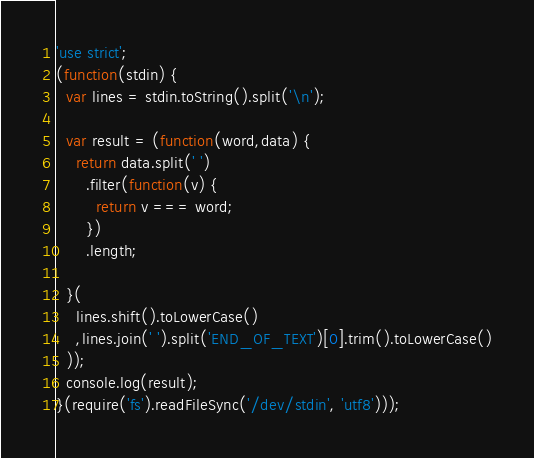<code> <loc_0><loc_0><loc_500><loc_500><_JavaScript_>'use strict';
(function(stdin) {
  var lines = stdin.toString().split('\n');
 
  var result = (function(word,data) {
    return data.split(' ')
      .filter(function(v) {
        return v === word;
      })
      .length;

  }(
    lines.shift().toLowerCase()
    ,lines.join(' ').split('END_OF_TEXT')[0].trim().toLowerCase()
  ));
  console.log(result);
}(require('fs').readFileSync('/dev/stdin', 'utf8')));</code> 